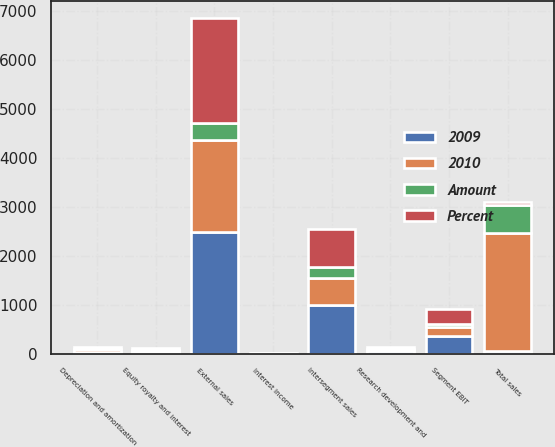Convert chart to OTSL. <chart><loc_0><loc_0><loc_500><loc_500><stacked_bar_chart><ecel><fcel>External sales<fcel>Intersegment sales<fcel>Total sales<fcel>Depreciation and amortization<fcel>Research development and<fcel>Equity royalty and interest<fcel>Interest income<fcel>Segment EBIT<nl><fcel>2009<fcel>2492<fcel>1006<fcel>51.5<fcel>42<fcel>54<fcel>47<fcel>8<fcel>373<nl><fcel>Percent<fcel>2150<fcel>769<fcel>51.5<fcel>41<fcel>36<fcel>35<fcel>5<fcel>299<nl><fcel>2010<fcel>1879<fcel>538<fcel>2417<fcel>49<fcel>33<fcel>22<fcel>3<fcel>167<nl><fcel>Amount<fcel>342<fcel>237<fcel>579<fcel>1<fcel>18<fcel>12<fcel>3<fcel>74<nl></chart> 